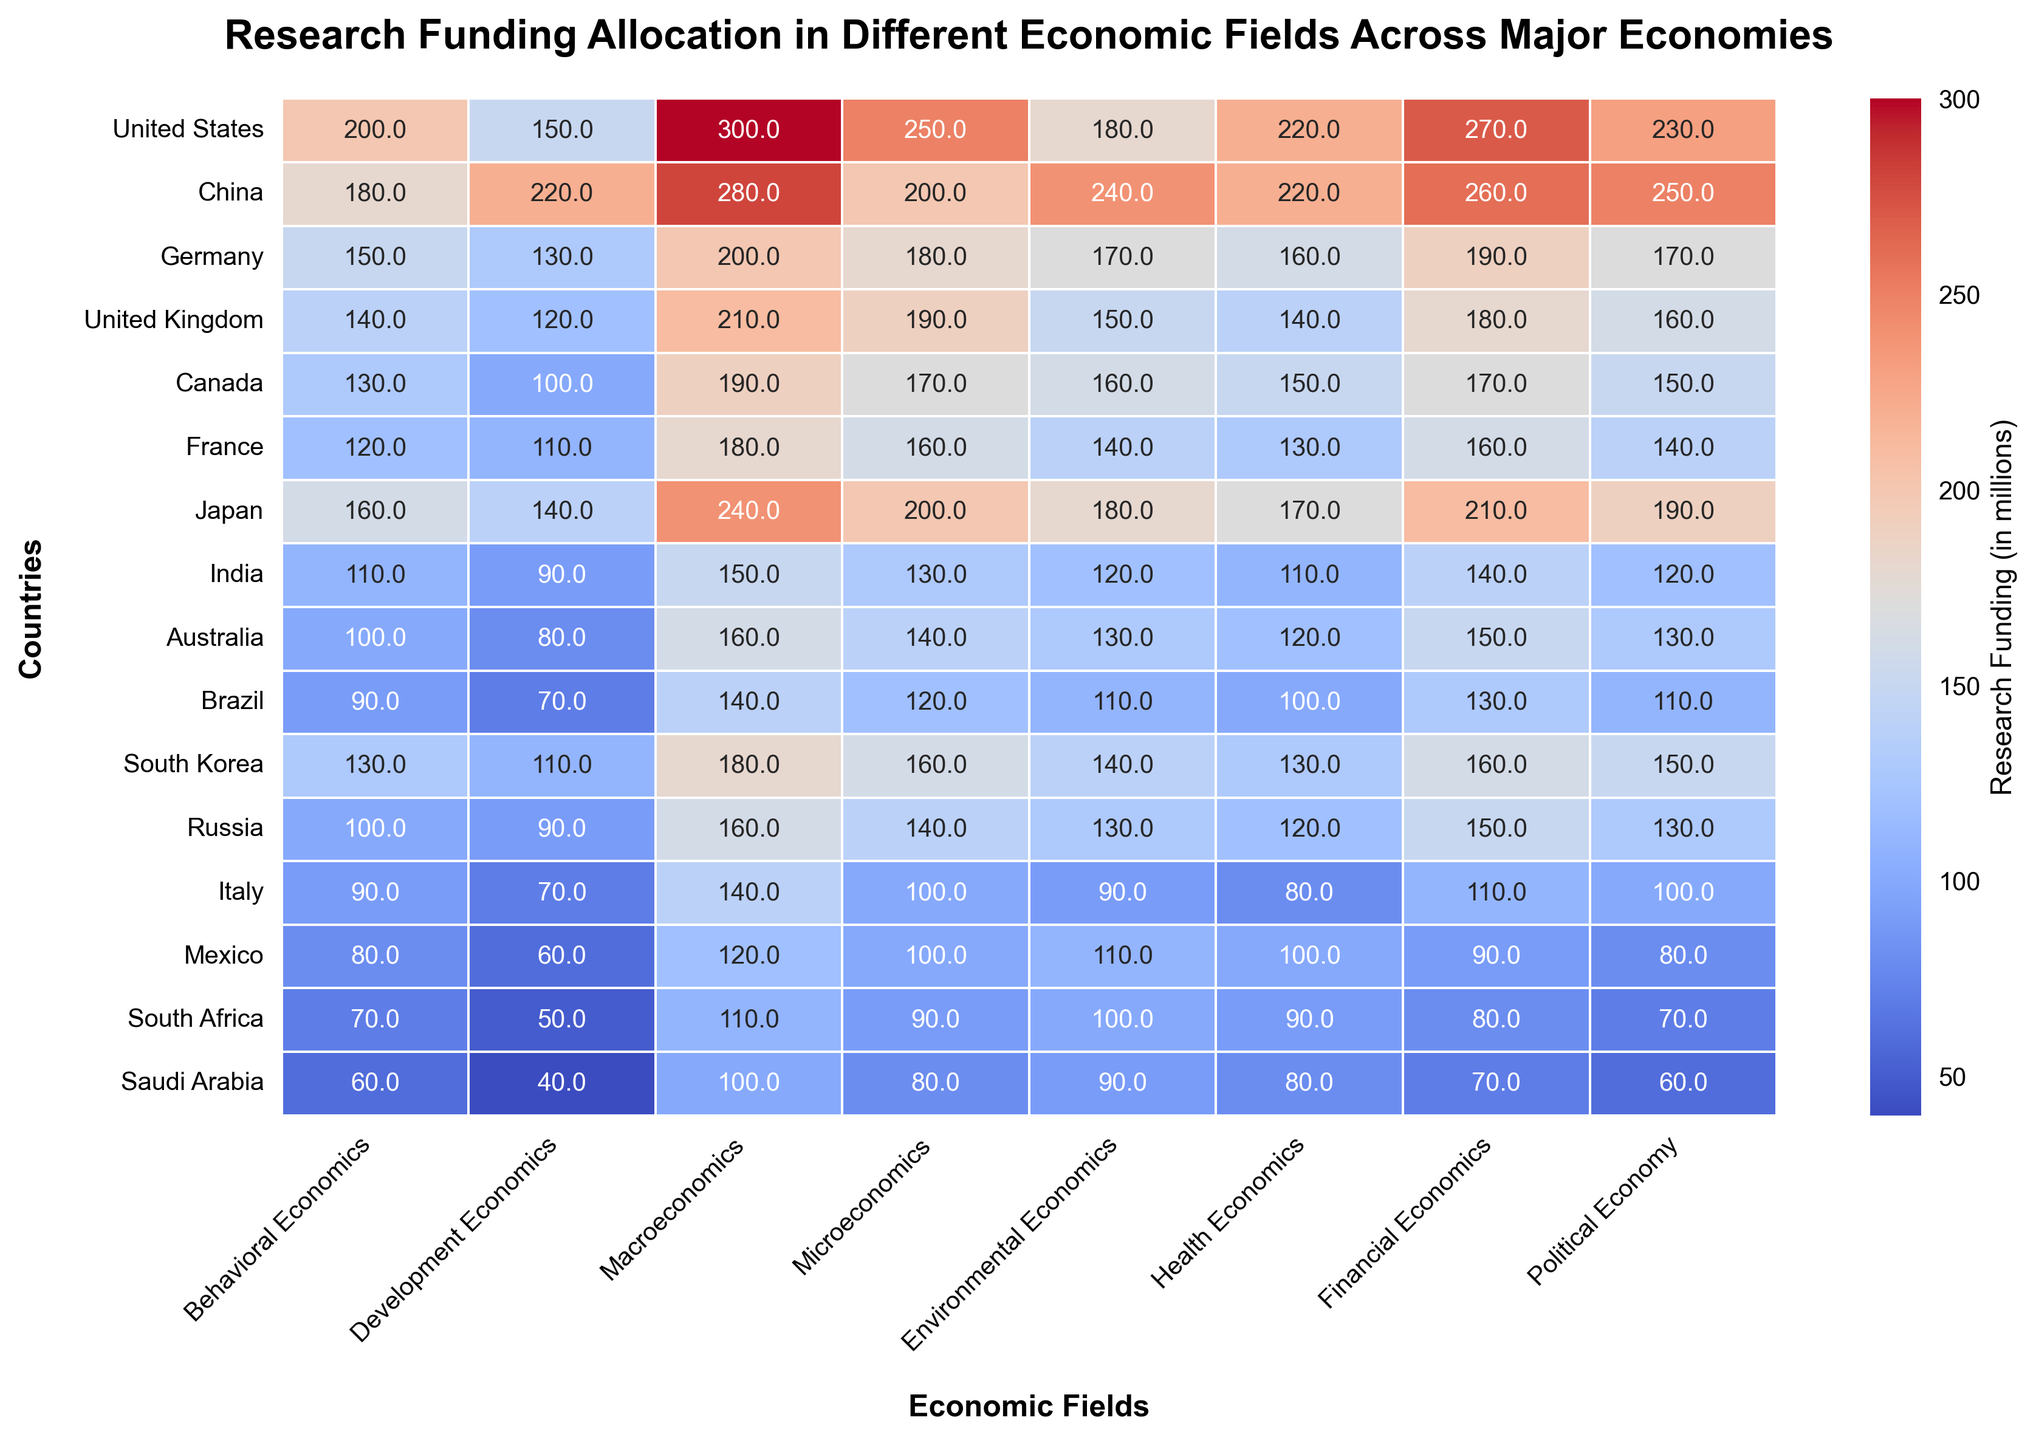Which country allocates the most research funding to Behavioral Economics? By examining the heatmap, we identify the country with the highest numerical value in the Behavioral Economics column. The United States allocates 200 million, which is the highest.
Answer: United States Which two countries provide the same amount of funding for Health Economics, and what is that amount? Investigate the Health Economics column to find identical numerical values. Both China and the United States allocate 220 million each.
Answer: China and United States, 220 million Comparing Macroeconomics funding, which country spends the least and how much is it? By determining the lowest value in the Macroeconomics column, we find that Saudi Arabia spends the least at 100 million.
Answer: Saudi Arabia, 100 million Calculate the average research funding for Financial Economics across all listed countries. Sum the values in the Financial Economics column and divide by the number of countries (15). The total is 2690, so the average is 2690/15 = 179.3.
Answer: 179.3 million Which countries invest an equal amount in Environmental Economics and what is that amount? Compare values in the Environmental Economics column to find equal amounts. Both Australia and Russia invest 130 million.
Answer: Australia and Russia, 130 million Which economic field does Japan allocate the most funding to, and how much? By finding the highest value in Japan's row across all fields, we see it allocates the most to Macroeconomics, with 240 million.
Answer: Macroeconomics, 240 million What is the funding difference in Microeconomics between Canada and Brazil? Subtract Brazil's funding in Microeconomics (120 million) from Canada's (170 million). The difference is 170-120 = 50 million.
Answer: 50 million Identify the color associated with high levels of research funding in the heatmap. The color corresponding to high research funding is observed to be warm, typically deep red in the heatmap.
Answer: Red Which country allocates more funding to Political Economy: South Korea or France, and by how much? Compare the Political Economy funding values: South Korea (150 million) and France (140 million). The difference is 10 million.
Answer: South Korea, 10 million Sum the research funding for Development Economics and Microeconomics for Germany, and what is the result? Add Germany's Development Economics funding (130 million) and Microeconomics funding (180 million). The sum is 130+180=310 million.
Answer: 310 million 